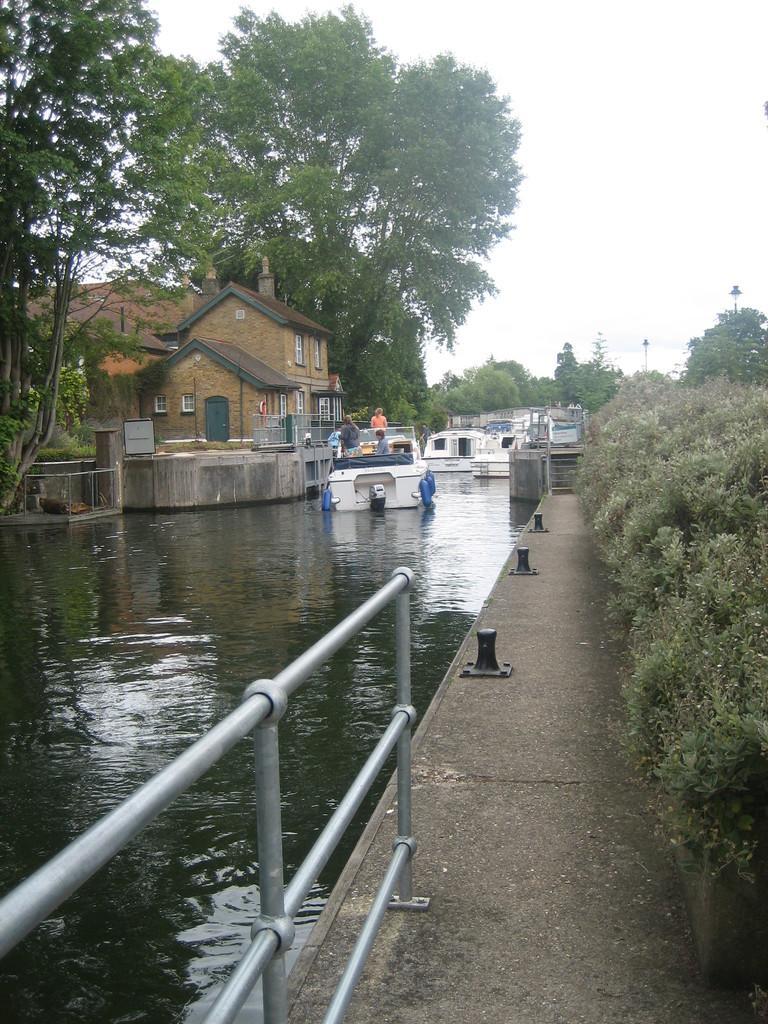Describe this image in one or two sentences. In this image I can see plants on the right side and on the left side this image I can see railing, water and on it I can see a boat and in the background I can see number of trees and few buildings. I can also see few lights on the right side of this image. 